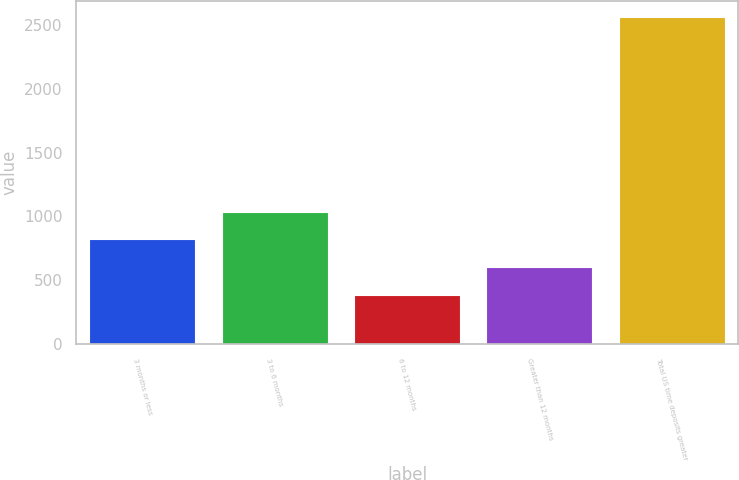Convert chart to OTSL. <chart><loc_0><loc_0><loc_500><loc_500><bar_chart><fcel>3 months or less<fcel>3 to 6 months<fcel>6 to 12 months<fcel>Greater than 12 months<fcel>Total US time deposits greater<nl><fcel>821<fcel>1038.5<fcel>386<fcel>603.5<fcel>2561<nl></chart> 